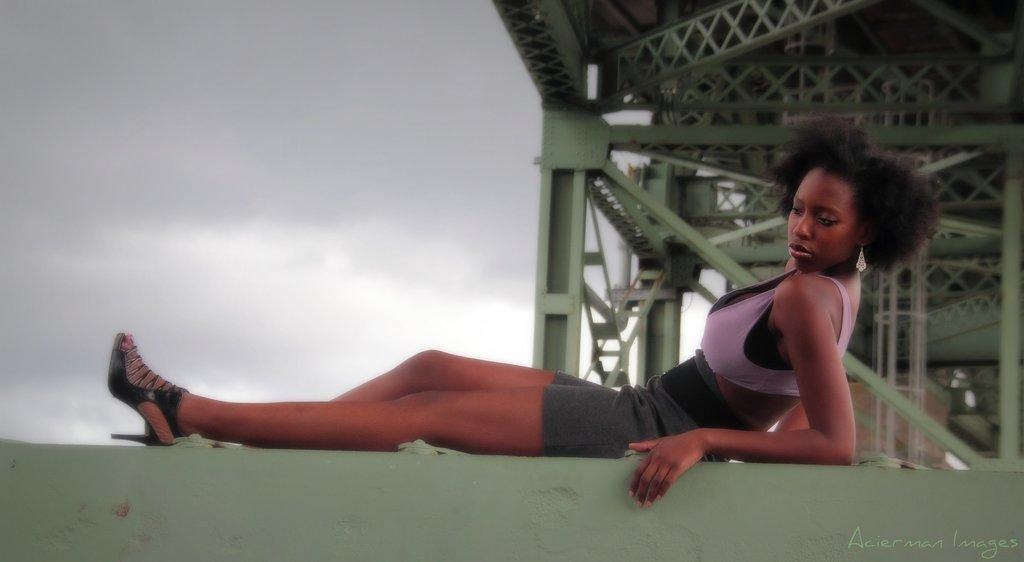What is the woman in the image doing? The woman is sitting in the image. What can be seen in the background of the image? There is a bridge visible in the background of the image. What is the condition of the sky in the image? The sky is full of clouds in the image. What type of salt is being used to season the woman's food in the image? There is no food or salt present in the image; it only features a woman sitting and a bridge in the background. 